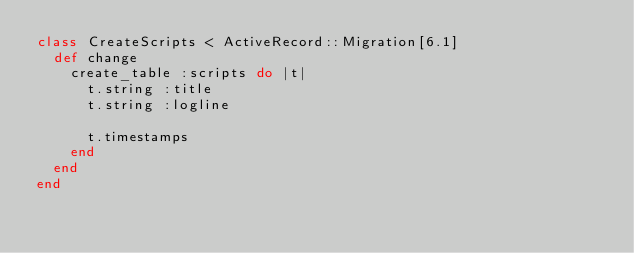Convert code to text. <code><loc_0><loc_0><loc_500><loc_500><_Ruby_>class CreateScripts < ActiveRecord::Migration[6.1]
  def change
    create_table :scripts do |t|
      t.string :title
      t.string :logline

      t.timestamps
    end
  end
end
</code> 